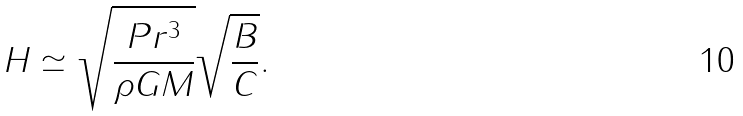<formula> <loc_0><loc_0><loc_500><loc_500>H \simeq \sqrt { \frac { P r ^ { 3 } } { \rho G M } } \sqrt { \frac { B } { C } } .</formula> 